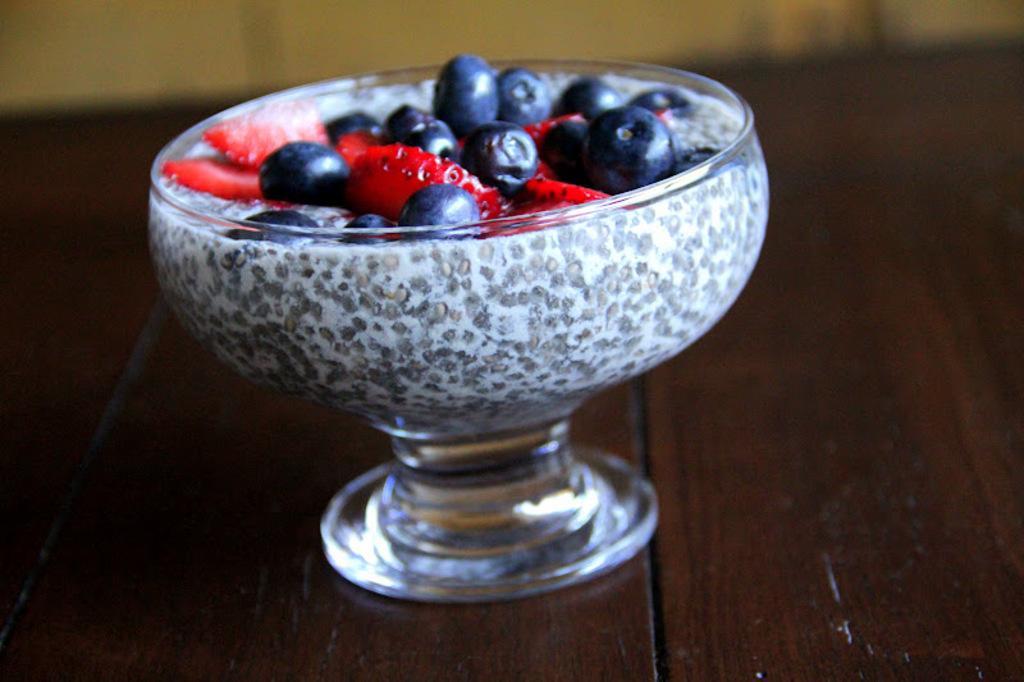In one or two sentences, can you explain what this image depicts? In this image there are some fruits are kept in a bowl as we can see in middle of this image , and this bowl is kept on one wooden object. 